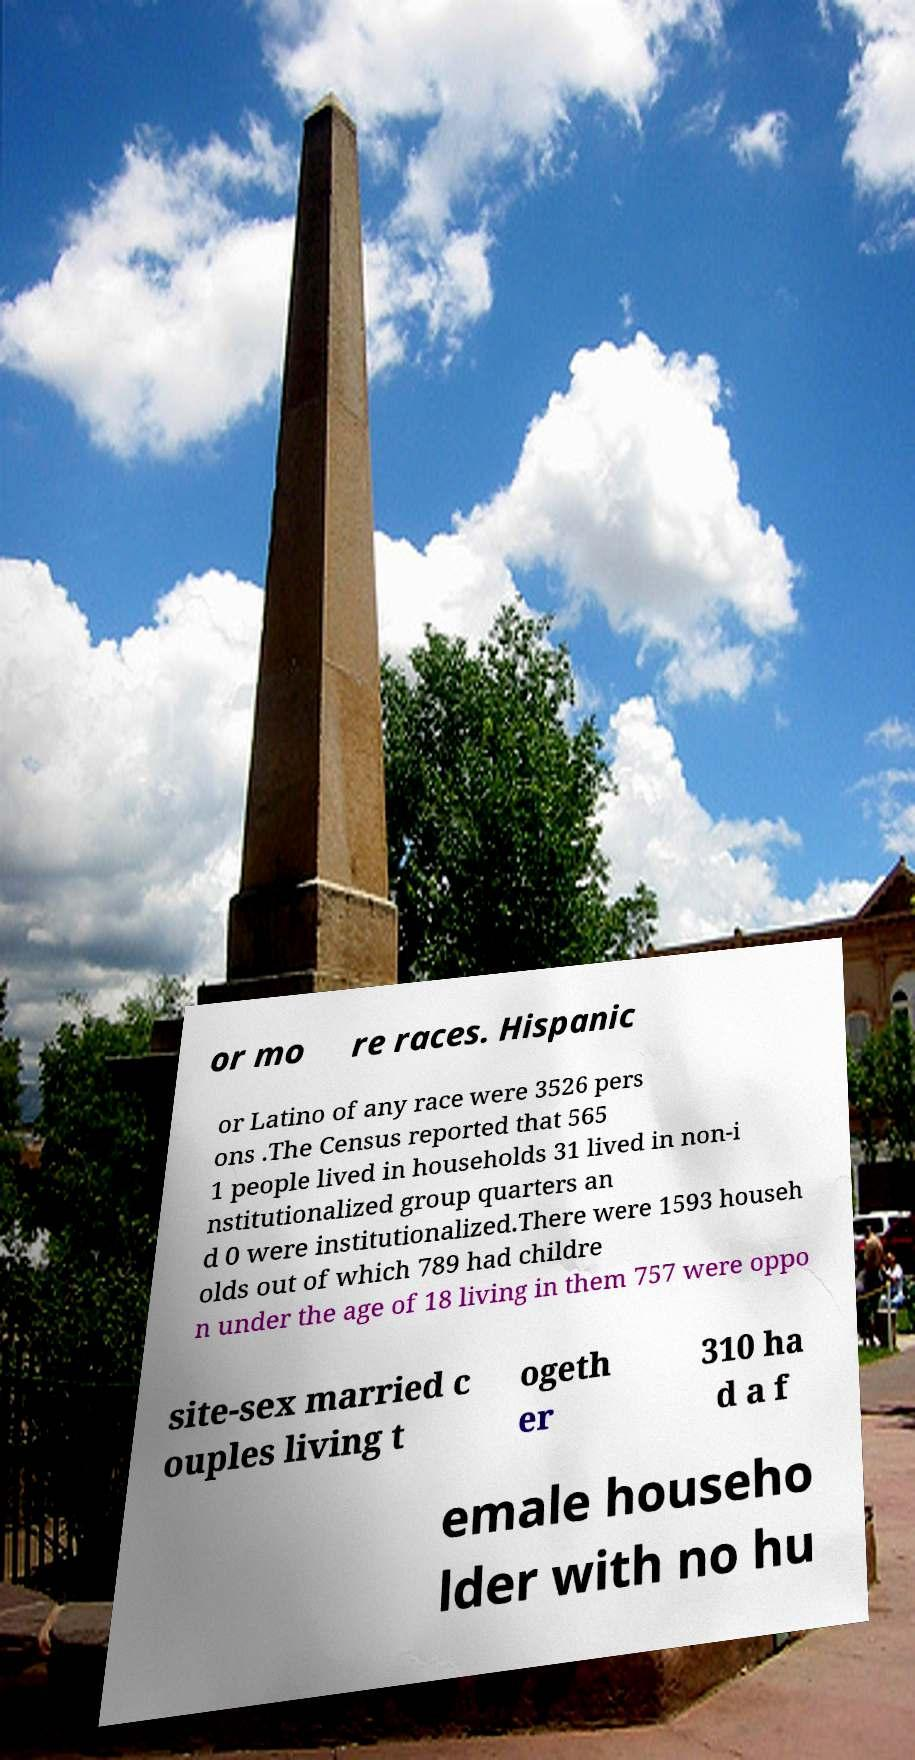Please identify and transcribe the text found in this image. or mo re races. Hispanic or Latino of any race were 3526 pers ons .The Census reported that 565 1 people lived in households 31 lived in non-i nstitutionalized group quarters an d 0 were institutionalized.There were 1593 househ olds out of which 789 had childre n under the age of 18 living in them 757 were oppo site-sex married c ouples living t ogeth er 310 ha d a f emale househo lder with no hu 